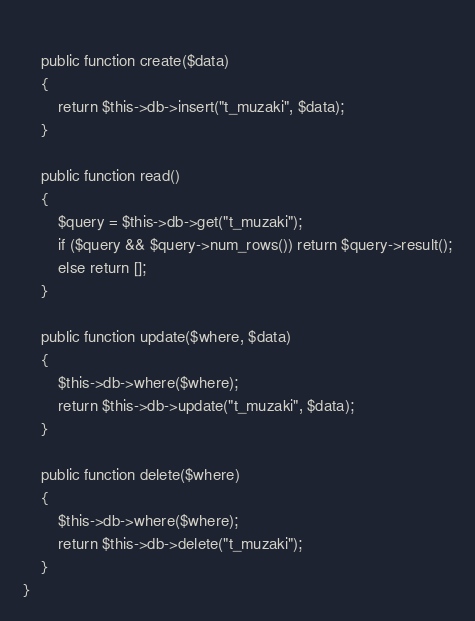Convert code to text. <code><loc_0><loc_0><loc_500><loc_500><_PHP_>    
    public function create($data)
    {
        return $this->db->insert("t_muzaki", $data);
    }
    
    public function read()
    {
        $query = $this->db->get("t_muzaki");
        if ($query && $query->num_rows()) return $query->result();
        else return [];
    }
    
    public function update($where, $data)
    {
        $this->db->where($where);
        return $this->db->update("t_muzaki", $data);
    }
    
    public function delete($where)
    {
        $this->db->where($where);
        return $this->db->delete("t_muzaki");
    }
}</code> 